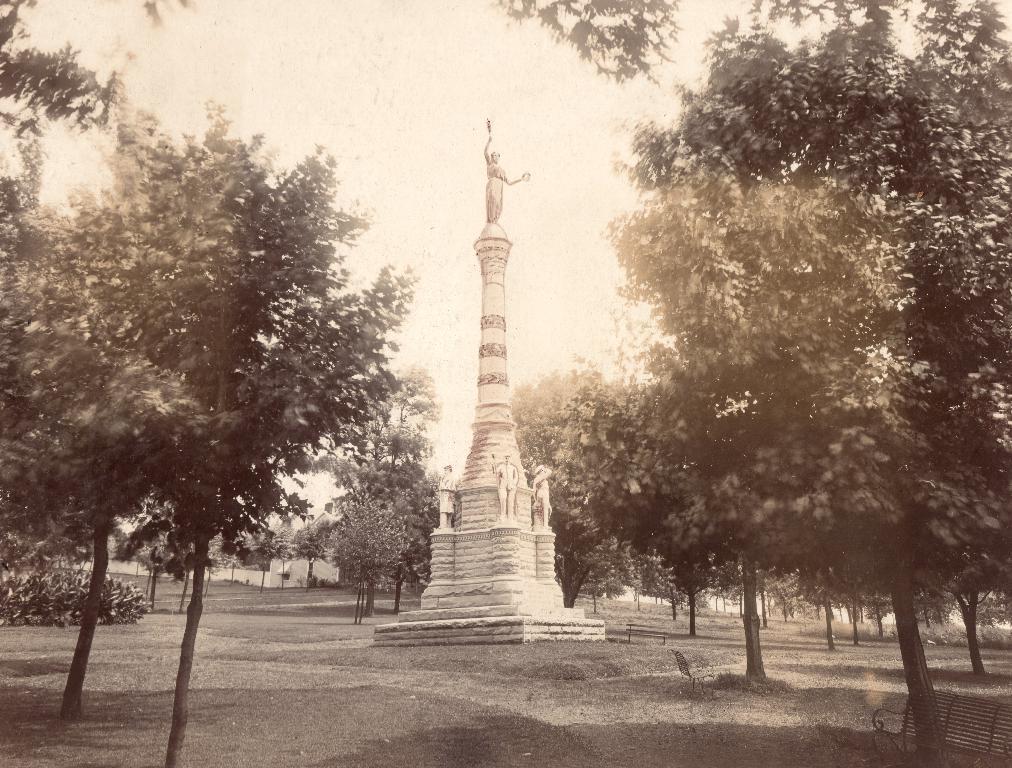Please provide a concise description of this image. In this picture I see a bench in front which is on the right bottom of this image and in the middle of this image I see number of trees and a statue and in the background I see the sky. 